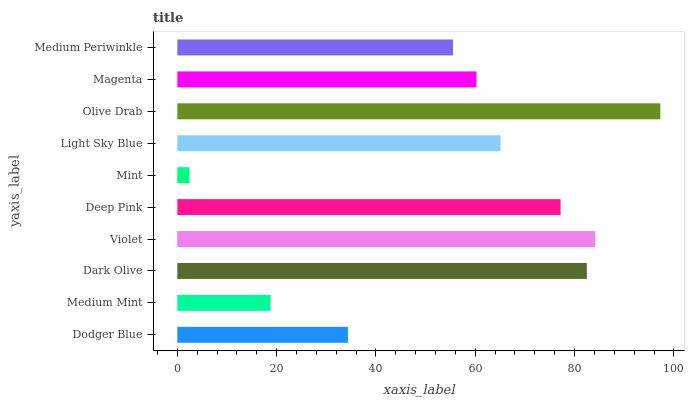Is Mint the minimum?
Answer yes or no. Yes. Is Olive Drab the maximum?
Answer yes or no. Yes. Is Medium Mint the minimum?
Answer yes or no. No. Is Medium Mint the maximum?
Answer yes or no. No. Is Dodger Blue greater than Medium Mint?
Answer yes or no. Yes. Is Medium Mint less than Dodger Blue?
Answer yes or no. Yes. Is Medium Mint greater than Dodger Blue?
Answer yes or no. No. Is Dodger Blue less than Medium Mint?
Answer yes or no. No. Is Light Sky Blue the high median?
Answer yes or no. Yes. Is Magenta the low median?
Answer yes or no. Yes. Is Dark Olive the high median?
Answer yes or no. No. Is Medium Periwinkle the low median?
Answer yes or no. No. 